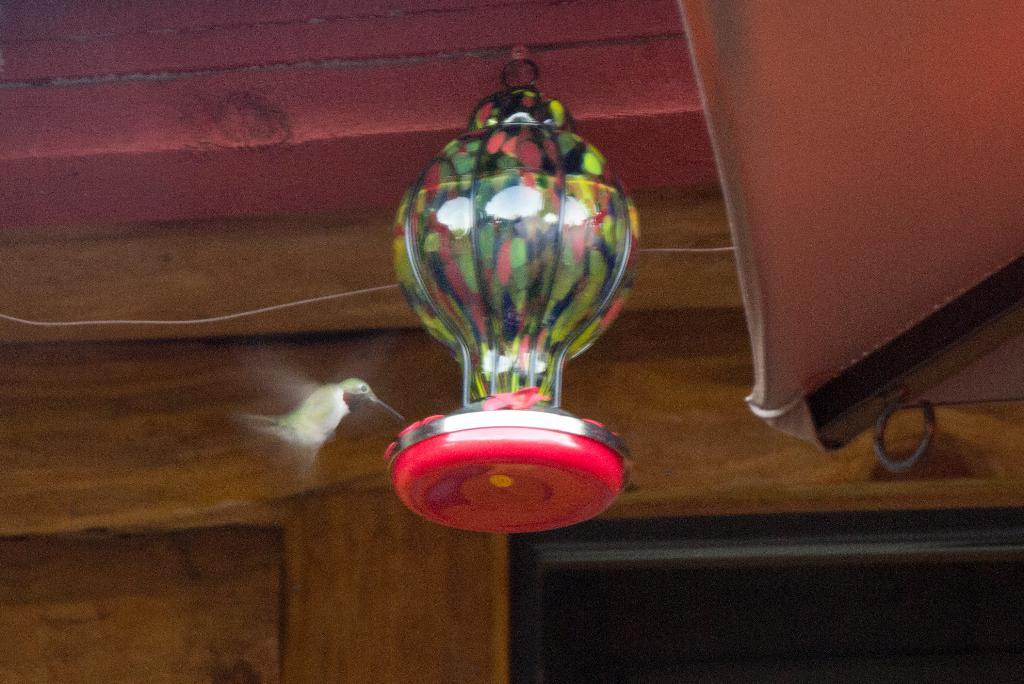What can be seen hanging from the ceiling in the image? There is a colorful object hanging from the ceiling in the image. What other living creature is present in the image? A bird is present near the hanging object. What color is the wall visible in the background of the image? There is a brown-colored wall in the background of the image. What type of order is being followed by the land in the image? There is no reference to land or any order in the image, so it is not possible to answer that question. 